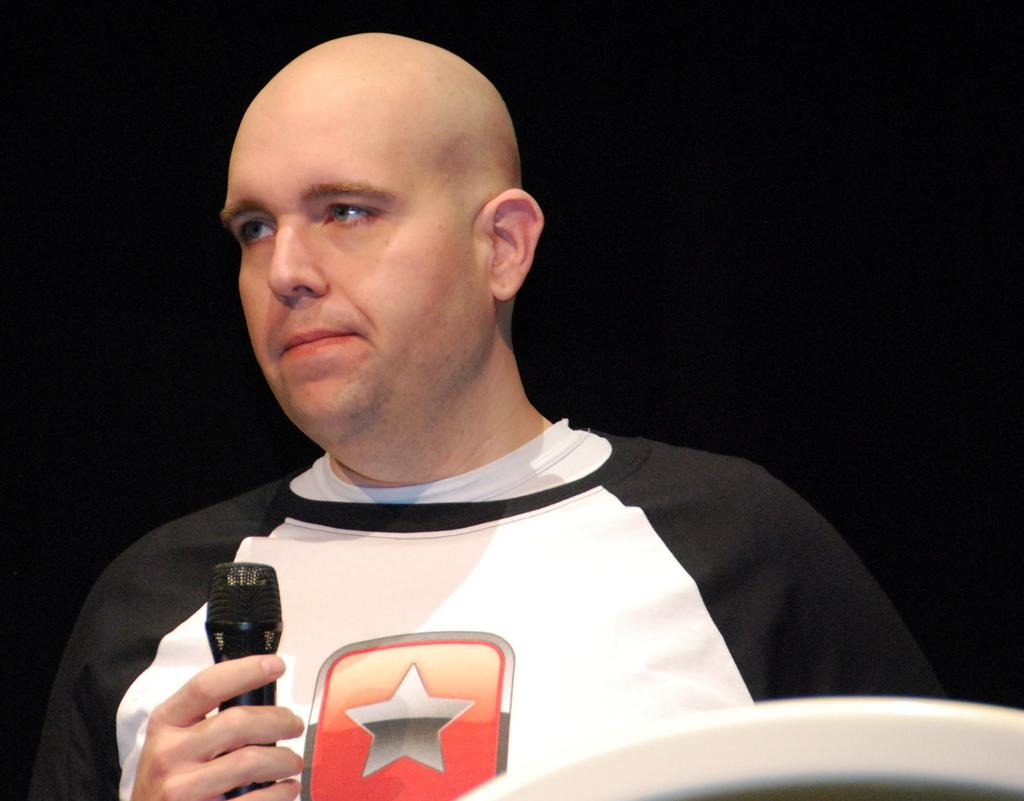What is the main subject of the image? The main subject of the image is a man. What is the man holding in his hand? The man is holding a microphone in his hand. What type of flowers can be seen growing around the man in the image? There are no flowers present in the image; it only features a man holding a microphone. What button is the man pressing while holding the microphone in the image? There is no button visible in the man pressing in the image; the man is simply holding a microphone. 